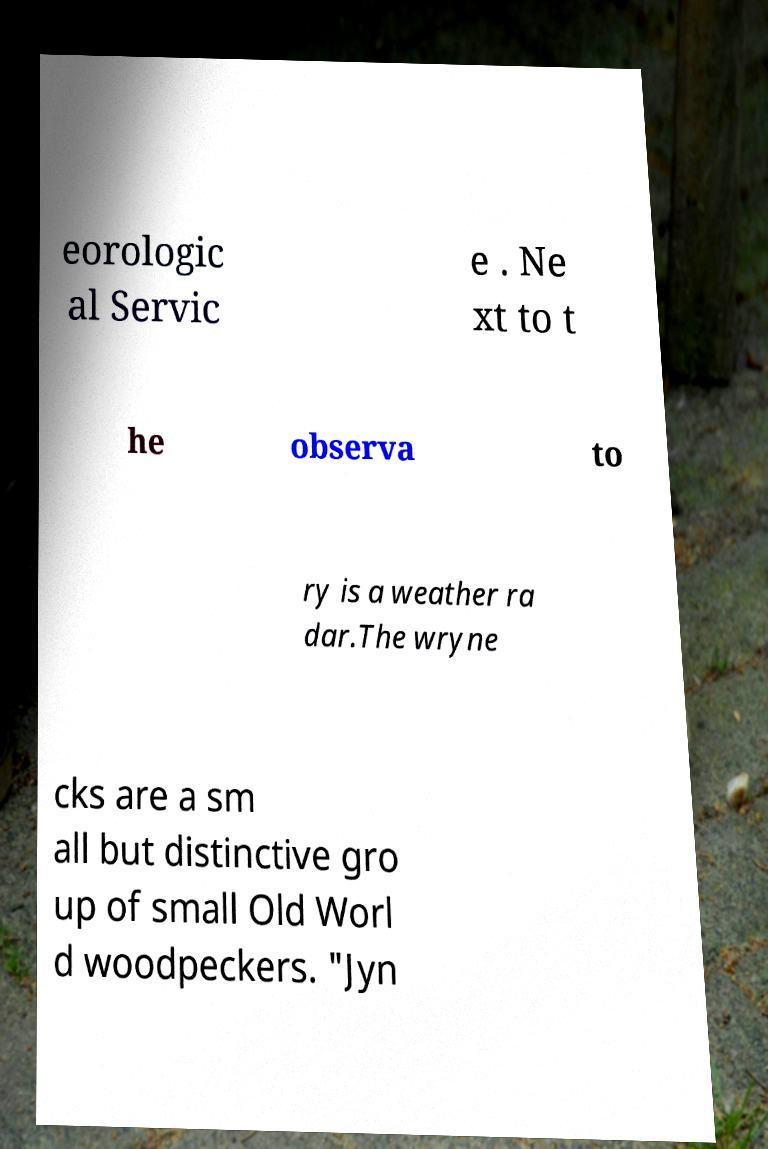Can you read and provide the text displayed in the image?This photo seems to have some interesting text. Can you extract and type it out for me? eorologic al Servic e . Ne xt to t he observa to ry is a weather ra dar.The wryne cks are a sm all but distinctive gro up of small Old Worl d woodpeckers. "Jyn 